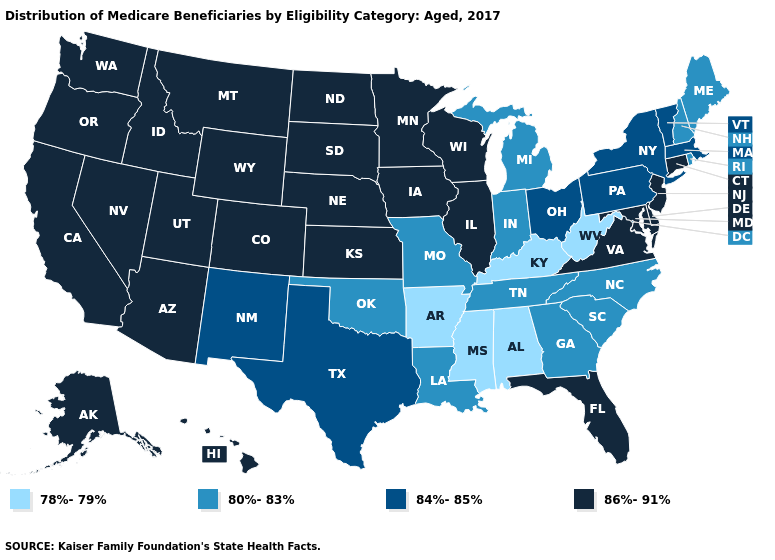What is the value of Pennsylvania?
Write a very short answer. 84%-85%. Does Nebraska have the highest value in the USA?
Answer briefly. Yes. What is the lowest value in the MidWest?
Keep it brief. 80%-83%. Does the first symbol in the legend represent the smallest category?
Concise answer only. Yes. Does Arizona have the highest value in the West?
Write a very short answer. Yes. Name the states that have a value in the range 86%-91%?
Short answer required. Alaska, Arizona, California, Colorado, Connecticut, Delaware, Florida, Hawaii, Idaho, Illinois, Iowa, Kansas, Maryland, Minnesota, Montana, Nebraska, Nevada, New Jersey, North Dakota, Oregon, South Dakota, Utah, Virginia, Washington, Wisconsin, Wyoming. What is the value of Ohio?
Write a very short answer. 84%-85%. What is the lowest value in states that border Colorado?
Short answer required. 80%-83%. What is the highest value in states that border Delaware?
Keep it brief. 86%-91%. What is the value of Kentucky?
Be succinct. 78%-79%. Name the states that have a value in the range 86%-91%?
Answer briefly. Alaska, Arizona, California, Colorado, Connecticut, Delaware, Florida, Hawaii, Idaho, Illinois, Iowa, Kansas, Maryland, Minnesota, Montana, Nebraska, Nevada, New Jersey, North Dakota, Oregon, South Dakota, Utah, Virginia, Washington, Wisconsin, Wyoming. What is the value of Washington?
Write a very short answer. 86%-91%. Does New Hampshire have the lowest value in the Northeast?
Write a very short answer. Yes. Name the states that have a value in the range 78%-79%?
Give a very brief answer. Alabama, Arkansas, Kentucky, Mississippi, West Virginia. 